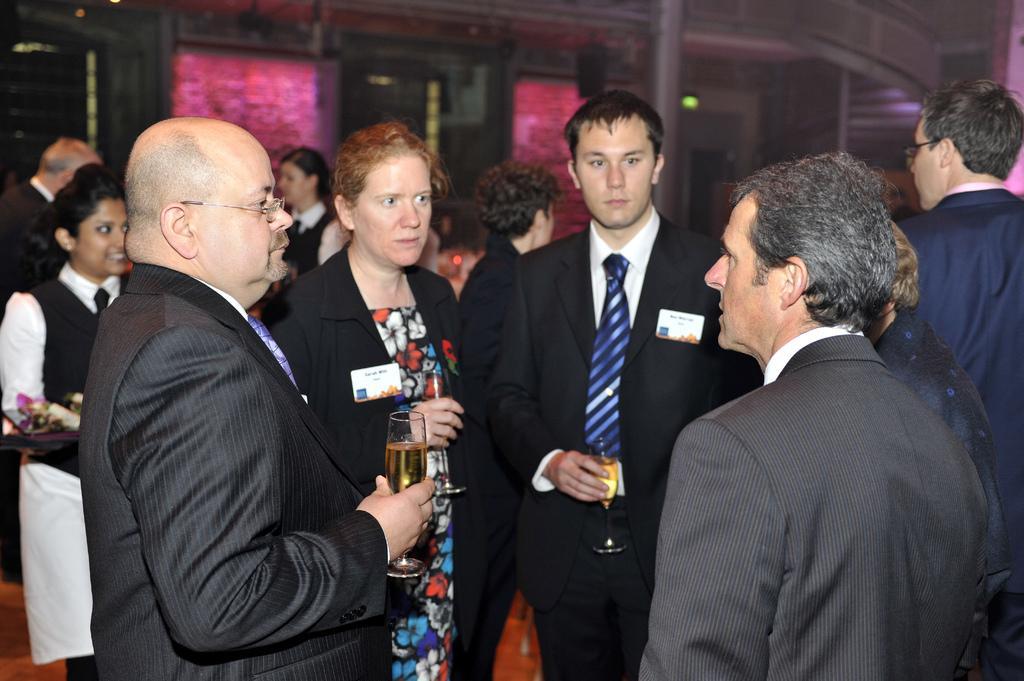Could you give a brief overview of what you see in this image? In this image we can see the people standing and a few people are standing and holding the drinks. In the background we can see the pink color boards, pillar and also lights. 